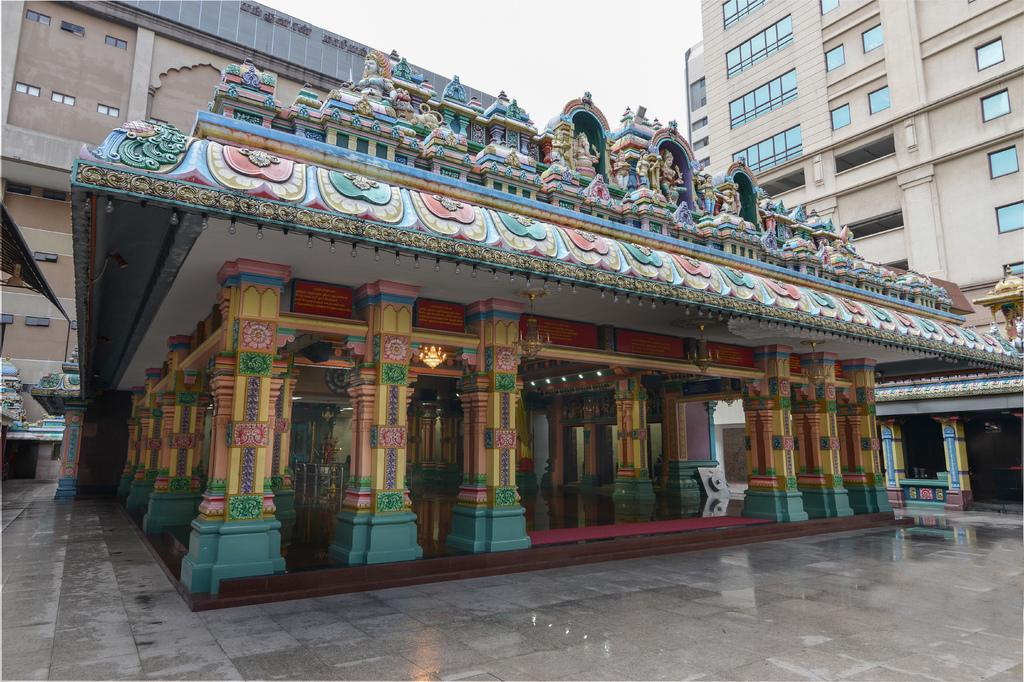What type of decorations can be seen on the building in the front of the image? There are sculptures on the building in the front of the image. What architectural features are present in the image? There are pillars in the image. What can be seen illuminating the scene in the image? There are lights in the image. What is visible in the distance in the image? There are buildings in the background of the image. How would you describe the weather based on the sky in the image? The sky is cloudy in the image. What type of nut is being used to measure the height of the sculptures in the image? There is no nut present in the image, nor is any measuring activity taking place. What is the reason for the protest happening in front of the building in the image? There is no protest present in the image; it only features sculptures, pillars, lights, and buildings. 